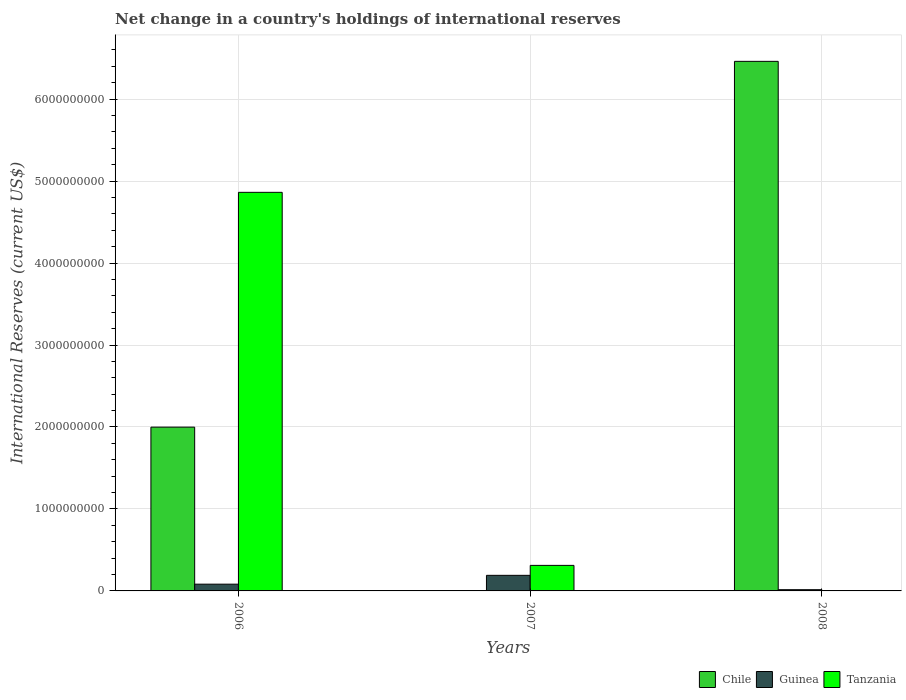How many different coloured bars are there?
Provide a short and direct response. 3. Are the number of bars per tick equal to the number of legend labels?
Offer a very short reply. No. Are the number of bars on each tick of the X-axis equal?
Your response must be concise. No. How many bars are there on the 3rd tick from the right?
Offer a terse response. 3. What is the label of the 3rd group of bars from the left?
Make the answer very short. 2008. What is the international reserves in Chile in 2008?
Provide a succinct answer. 6.46e+09. Across all years, what is the maximum international reserves in Tanzania?
Keep it short and to the point. 4.86e+09. Across all years, what is the minimum international reserves in Chile?
Provide a succinct answer. 0. In which year was the international reserves in Guinea maximum?
Provide a succinct answer. 2007. What is the total international reserves in Guinea in the graph?
Your answer should be very brief. 2.88e+08. What is the difference between the international reserves in Guinea in 2006 and that in 2008?
Your answer should be compact. 6.74e+07. What is the average international reserves in Guinea per year?
Give a very brief answer. 9.59e+07. In the year 2008, what is the difference between the international reserves in Guinea and international reserves in Chile?
Offer a terse response. -6.45e+09. In how many years, is the international reserves in Tanzania greater than 5400000000 US$?
Provide a short and direct response. 0. What is the ratio of the international reserves in Guinea in 2007 to that in 2008?
Make the answer very short. 12.68. What is the difference between the highest and the second highest international reserves in Guinea?
Your answer should be compact. 1.08e+08. What is the difference between the highest and the lowest international reserves in Chile?
Ensure brevity in your answer.  6.46e+09. Does the graph contain any zero values?
Ensure brevity in your answer.  Yes. Does the graph contain grids?
Give a very brief answer. Yes. How many legend labels are there?
Your answer should be very brief. 3. What is the title of the graph?
Your response must be concise. Net change in a country's holdings of international reserves. Does "Maldives" appear as one of the legend labels in the graph?
Provide a short and direct response. No. What is the label or title of the X-axis?
Your answer should be compact. Years. What is the label or title of the Y-axis?
Offer a very short reply. International Reserves (current US$). What is the International Reserves (current US$) in Chile in 2006?
Give a very brief answer. 2.00e+09. What is the International Reserves (current US$) of Guinea in 2006?
Provide a succinct answer. 8.24e+07. What is the International Reserves (current US$) of Tanzania in 2006?
Offer a terse response. 4.86e+09. What is the International Reserves (current US$) in Chile in 2007?
Offer a very short reply. 0. What is the International Reserves (current US$) in Guinea in 2007?
Offer a very short reply. 1.90e+08. What is the International Reserves (current US$) of Tanzania in 2007?
Provide a succinct answer. 3.12e+08. What is the International Reserves (current US$) in Chile in 2008?
Offer a very short reply. 6.46e+09. What is the International Reserves (current US$) in Guinea in 2008?
Make the answer very short. 1.50e+07. What is the International Reserves (current US$) in Tanzania in 2008?
Keep it short and to the point. 0. Across all years, what is the maximum International Reserves (current US$) in Chile?
Your response must be concise. 6.46e+09. Across all years, what is the maximum International Reserves (current US$) of Guinea?
Your response must be concise. 1.90e+08. Across all years, what is the maximum International Reserves (current US$) of Tanzania?
Provide a short and direct response. 4.86e+09. Across all years, what is the minimum International Reserves (current US$) in Chile?
Make the answer very short. 0. Across all years, what is the minimum International Reserves (current US$) of Guinea?
Your answer should be very brief. 1.50e+07. What is the total International Reserves (current US$) of Chile in the graph?
Offer a terse response. 8.46e+09. What is the total International Reserves (current US$) in Guinea in the graph?
Your answer should be very brief. 2.88e+08. What is the total International Reserves (current US$) in Tanzania in the graph?
Offer a terse response. 5.17e+09. What is the difference between the International Reserves (current US$) in Guinea in 2006 and that in 2007?
Provide a short and direct response. -1.08e+08. What is the difference between the International Reserves (current US$) of Tanzania in 2006 and that in 2007?
Ensure brevity in your answer.  4.55e+09. What is the difference between the International Reserves (current US$) in Chile in 2006 and that in 2008?
Keep it short and to the point. -4.46e+09. What is the difference between the International Reserves (current US$) in Guinea in 2006 and that in 2008?
Offer a very short reply. 6.74e+07. What is the difference between the International Reserves (current US$) of Guinea in 2007 and that in 2008?
Your answer should be compact. 1.75e+08. What is the difference between the International Reserves (current US$) of Chile in 2006 and the International Reserves (current US$) of Guinea in 2007?
Provide a short and direct response. 1.81e+09. What is the difference between the International Reserves (current US$) of Chile in 2006 and the International Reserves (current US$) of Tanzania in 2007?
Keep it short and to the point. 1.69e+09. What is the difference between the International Reserves (current US$) of Guinea in 2006 and the International Reserves (current US$) of Tanzania in 2007?
Offer a very short reply. -2.29e+08. What is the difference between the International Reserves (current US$) in Chile in 2006 and the International Reserves (current US$) in Guinea in 2008?
Offer a terse response. 1.98e+09. What is the average International Reserves (current US$) in Chile per year?
Give a very brief answer. 2.82e+09. What is the average International Reserves (current US$) of Guinea per year?
Offer a very short reply. 9.59e+07. What is the average International Reserves (current US$) of Tanzania per year?
Make the answer very short. 1.72e+09. In the year 2006, what is the difference between the International Reserves (current US$) of Chile and International Reserves (current US$) of Guinea?
Your response must be concise. 1.92e+09. In the year 2006, what is the difference between the International Reserves (current US$) of Chile and International Reserves (current US$) of Tanzania?
Your response must be concise. -2.86e+09. In the year 2006, what is the difference between the International Reserves (current US$) in Guinea and International Reserves (current US$) in Tanzania?
Offer a terse response. -4.78e+09. In the year 2007, what is the difference between the International Reserves (current US$) of Guinea and International Reserves (current US$) of Tanzania?
Your answer should be compact. -1.21e+08. In the year 2008, what is the difference between the International Reserves (current US$) in Chile and International Reserves (current US$) in Guinea?
Ensure brevity in your answer.  6.45e+09. What is the ratio of the International Reserves (current US$) of Guinea in 2006 to that in 2007?
Keep it short and to the point. 0.43. What is the ratio of the International Reserves (current US$) in Tanzania in 2006 to that in 2007?
Keep it short and to the point. 15.6. What is the ratio of the International Reserves (current US$) in Chile in 2006 to that in 2008?
Provide a short and direct response. 0.31. What is the ratio of the International Reserves (current US$) of Guinea in 2006 to that in 2008?
Ensure brevity in your answer.  5.49. What is the ratio of the International Reserves (current US$) of Guinea in 2007 to that in 2008?
Make the answer very short. 12.68. What is the difference between the highest and the second highest International Reserves (current US$) in Guinea?
Your answer should be compact. 1.08e+08. What is the difference between the highest and the lowest International Reserves (current US$) in Chile?
Your answer should be compact. 6.46e+09. What is the difference between the highest and the lowest International Reserves (current US$) in Guinea?
Offer a terse response. 1.75e+08. What is the difference between the highest and the lowest International Reserves (current US$) of Tanzania?
Offer a terse response. 4.86e+09. 